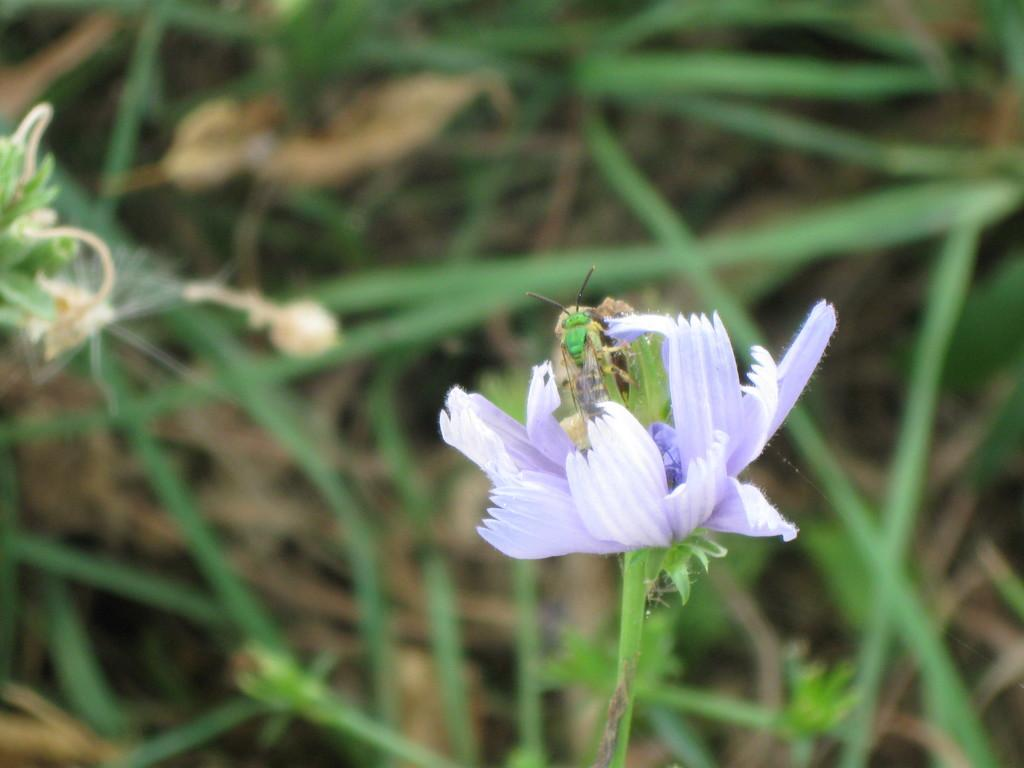What is present in the image? There is an insect in the image. Where is the insect located? The insect is on a flower. What part of the image do the insect and flower occupy? The insect and flower are in the foreground area of the image. Can you tell me how much the zoo visit receipt costs in the image? There is no zoo visit receipt present in the image; it features an insect on a flower. What type of rod is being used by the insect to climb the flower in the image? There is no rod visible in the image; the insect is simply on the flower. 